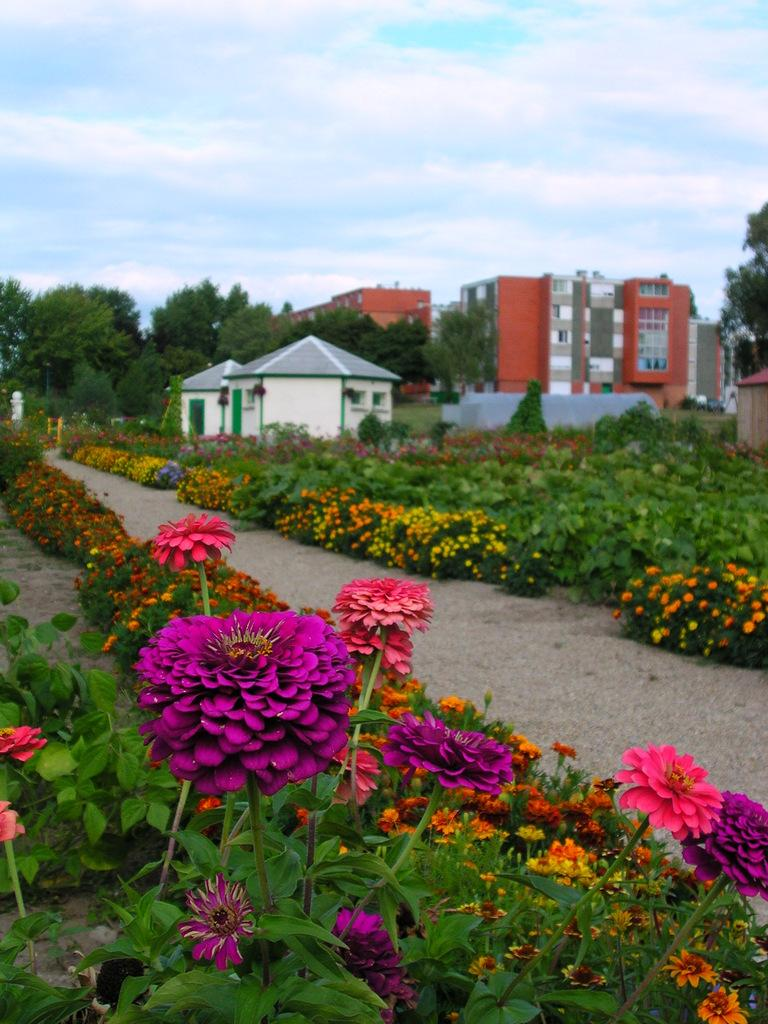What can be seen in the image that people might walk on? There is a path in the image that people might walk on. What type of plants are present alongside the path? Plants with flowers are present on either side of the path. What can be seen in the distance in the image? There are buildings and trees visible in the background of the image. What else is present in the background of the image? Plants and clouds are visible in the background of the image. Can you tell me how many skateboards are visible in the image? There are no skateboards present in the image. What type of sister is shown interacting with the plants in the image? There is no sister present in the image; it features a path with plants and flowers alongside it. 